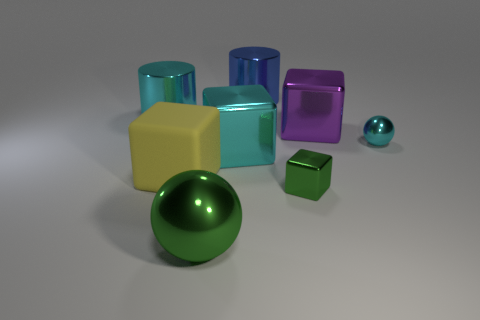There is a big cube that is the same color as the tiny ball; what is it made of?
Offer a terse response. Metal. The large cube that is on the left side of the big metallic cube on the left side of the block that is behind the cyan metallic sphere is made of what material?
Give a very brief answer. Rubber. There is a cube that is the same color as the big metallic sphere; what is its size?
Give a very brief answer. Small. What is the material of the yellow block?
Offer a terse response. Rubber. Does the large purple cube have the same material as the cyan thing that is on the left side of the big green ball?
Give a very brief answer. Yes. There is a ball that is on the right side of the cylinder on the right side of the rubber block; what color is it?
Make the answer very short. Cyan. What is the size of the thing that is both behind the yellow cube and left of the large metal sphere?
Offer a very short reply. Large. What number of other things are the same shape as the yellow object?
Offer a terse response. 3. Does the small green object have the same shape as the cyan shiny object that is right of the blue metal object?
Provide a succinct answer. No. What number of blue objects are in front of the small metallic block?
Ensure brevity in your answer.  0. 